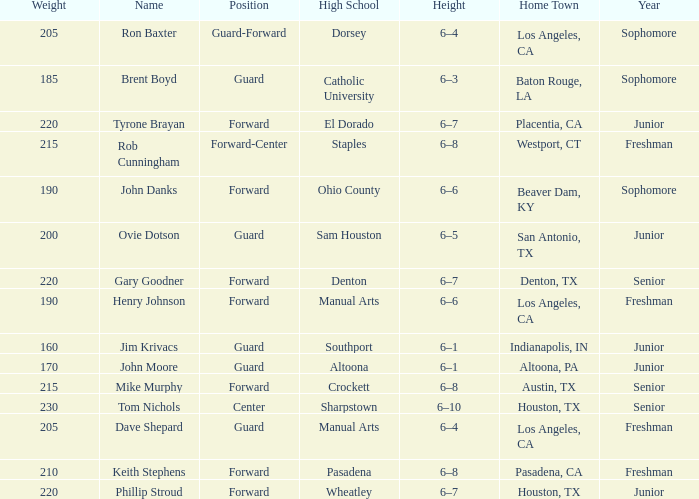What is the name including a year of an underclassman, and a high school related to wheatley? Phillip Stroud. 